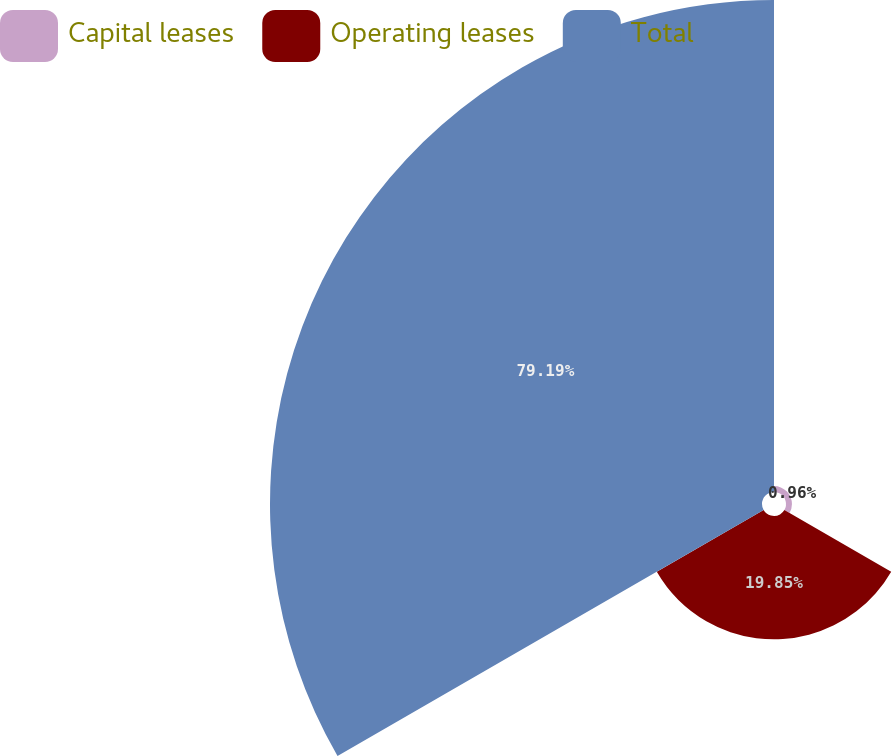Convert chart to OTSL. <chart><loc_0><loc_0><loc_500><loc_500><pie_chart><fcel>Capital leases<fcel>Operating leases<fcel>Total<nl><fcel>0.96%<fcel>19.85%<fcel>79.19%<nl></chart> 